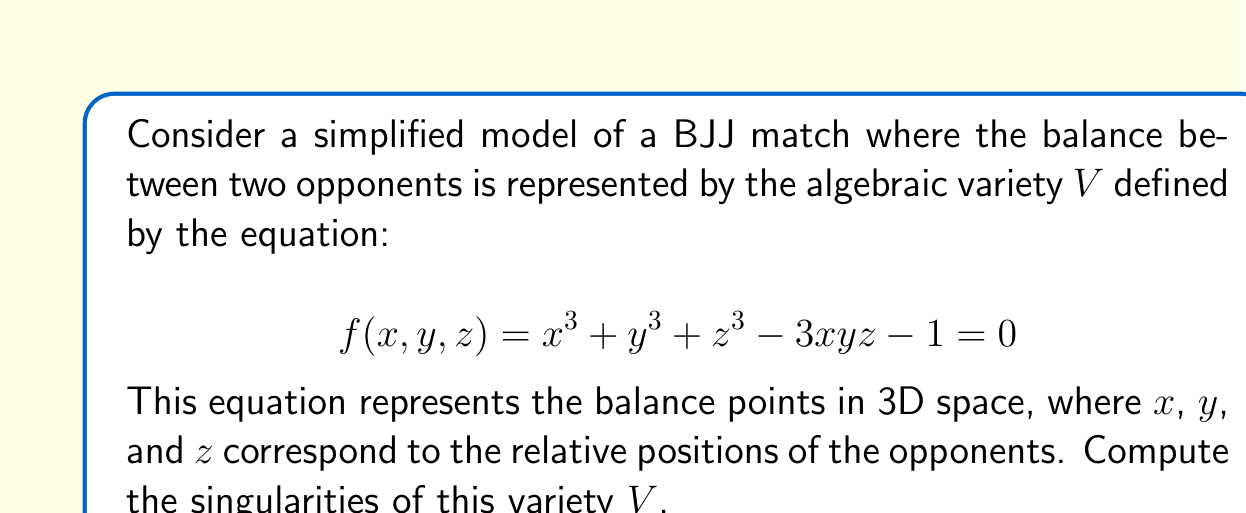Teach me how to tackle this problem. To find the singularities of the variety $V$, we need to follow these steps:

1) Singularities occur at points where all partial derivatives of $f$ are zero simultaneously with $f = 0$. Let's calculate the partial derivatives:

   $$ \frac{\partial f}{\partial x} = 3x^2 - 3yz $$
   $$ \frac{\partial f}{\partial y} = 3y^2 - 3xz $$
   $$ \frac{\partial f}{\partial z} = 3z^2 - 3xy $$

2) Set up the system of equations:

   $$ x^3 + y^3 + z^3 - 3xyz - 1 = 0 $$
   $$ 3x^2 - 3yz = 0 $$
   $$ 3y^2 - 3xz = 0 $$
   $$ 3z^2 - 3xy = 0 $$

3) From the last three equations, we can deduce:
   $$ x^2 = yz, \quad y^2 = xz, \quad z^2 = xy $$

4) Multiplying these equations:
   $$ x^2y^2z^2 = (yz)(xz)(xy) = x^2y^2z^2 $$

   This is always true, so it doesn't give us new information.

5) Substituting $x^2 = yz$ into $z^2 = xy$:
   $$ z^2 = x(x^2/z) = x^3/z $$
   $$ z^3 = x^3 $$

6) Similarly, we can show that $x^3 = y^3 = z^3$. Let's call this common value $a^3$.

7) So, $x = y = z = a$ where $a$ is a cube root of unity. Substituting back into the original equation:

   $$ a^3 + a^3 + a^3 - 3a^3 - 1 = 0 $$
   $$ 3a^3 - 3a^3 - 1 = 0 $$
   $$ -1 = 0 $$

8) This is a contradiction, meaning there are no points that satisfy all the equations simultaneously.

Therefore, the variety $V$ has no singularities.
Answer: The variety $V$ has no singularities. 